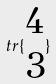Convert formula to latex. <formula><loc_0><loc_0><loc_500><loc_500>t r \{ \begin{matrix} 4 \\ 3 \end{matrix} \}</formula> 